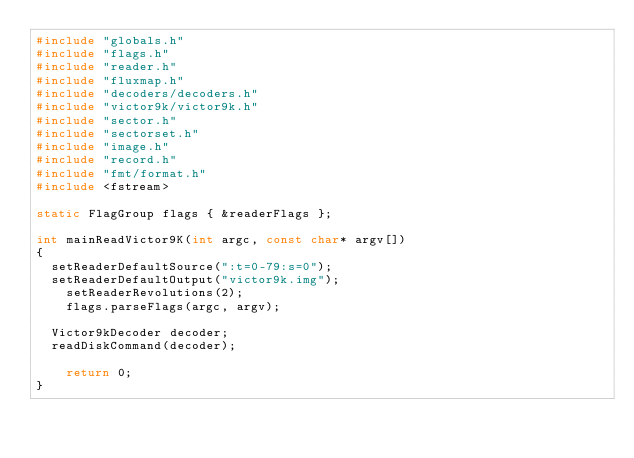Convert code to text. <code><loc_0><loc_0><loc_500><loc_500><_C++_>#include "globals.h"
#include "flags.h"
#include "reader.h"
#include "fluxmap.h"
#include "decoders/decoders.h"
#include "victor9k/victor9k.h"
#include "sector.h"
#include "sectorset.h"
#include "image.h"
#include "record.h"
#include "fmt/format.h"
#include <fstream>

static FlagGroup flags { &readerFlags };

int mainReadVictor9K(int argc, const char* argv[])
{
	setReaderDefaultSource(":t=0-79:s=0");
	setReaderDefaultOutput("victor9k.img");
    setReaderRevolutions(2);
    flags.parseFlags(argc, argv);

	Victor9kDecoder decoder;
	readDiskCommand(decoder);

    return 0;
}

</code> 